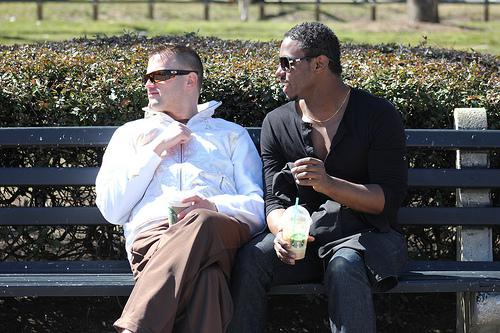Question: how many people are there?
Choices:
A. Two.
B. Three.
C. Four.
D. Six.
Answer with the letter. Answer: A Question: when was the photo taken?
Choices:
A. At night.
B. At dusk.
C. At twilight.
D. During the day.
Answer with the letter. Answer: D Question: who is sitting on the bench?
Choices:
A. Two women.
B. Three men.
C. Two men.
D. Three women.
Answer with the letter. Answer: C Question: what is the man holding?
Choices:
A. A Dunkin Donuts cup.
B. A McDonalds cup.
C. A starbucks cup.
D. A Burger King cup.
Answer with the letter. Answer: C 